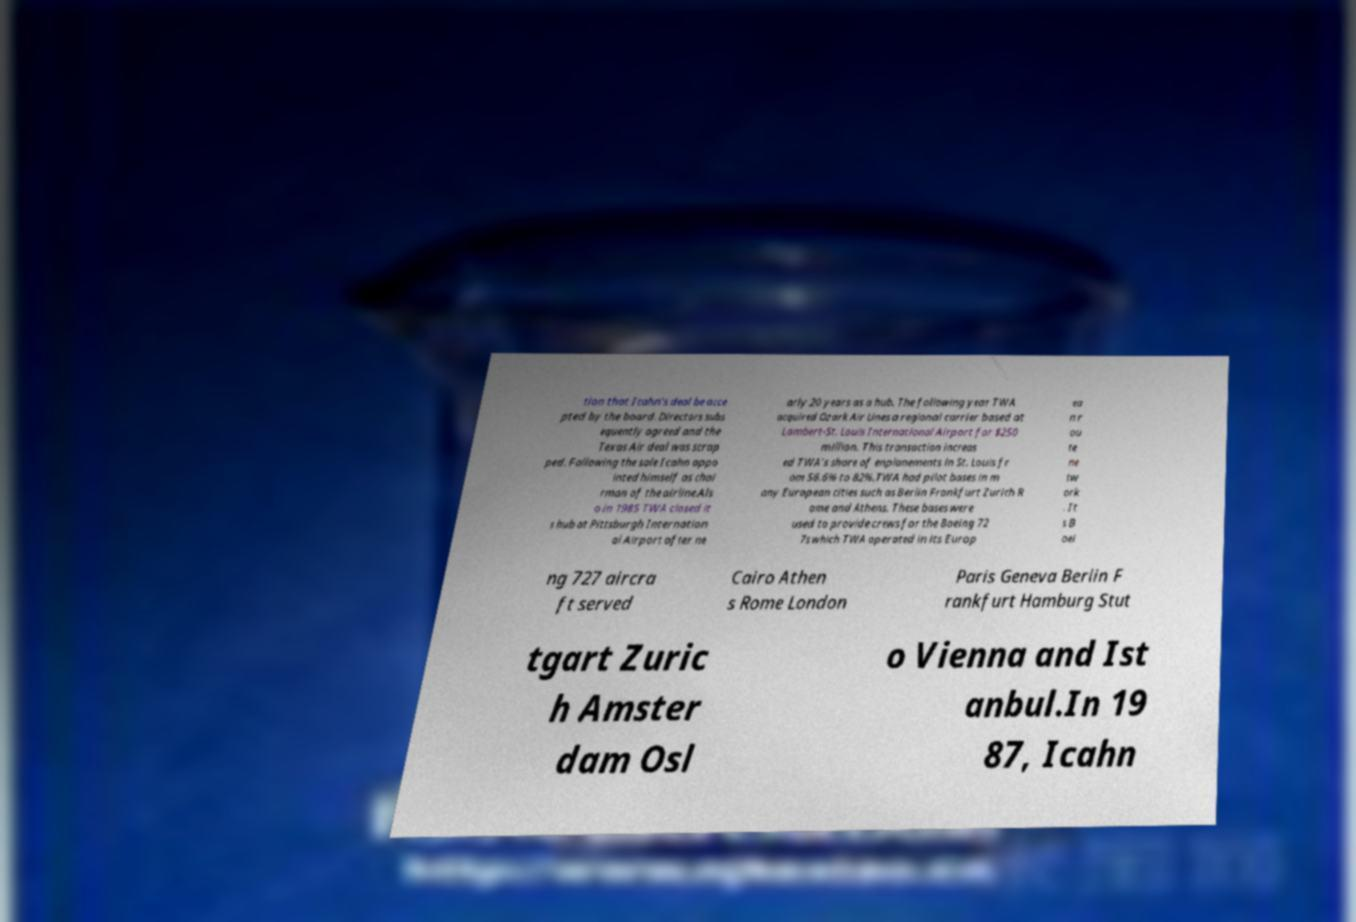What messages or text are displayed in this image? I need them in a readable, typed format. tion that Icahn's deal be acce pted by the board. Directors subs equently agreed and the Texas Air deal was scrap ped. Following the sale Icahn appo inted himself as chai rman of the airline.Als o in 1985 TWA closed it s hub at Pittsburgh Internation al Airport after ne arly 20 years as a hub. The following year TWA acquired Ozark Air Lines a regional carrier based at Lambert-St. Louis International Airport for $250 million. This transaction increas ed TWA's share of enplanements in St. Louis fr om 56.6% to 82%.TWA had pilot bases in m any European cities such as Berlin Frankfurt Zurich R ome and Athens. These bases were used to provide crews for the Boeing 72 7s which TWA operated in its Europ ea n r ou te ne tw ork . It s B oei ng 727 aircra ft served Cairo Athen s Rome London Paris Geneva Berlin F rankfurt Hamburg Stut tgart Zuric h Amster dam Osl o Vienna and Ist anbul.In 19 87, Icahn 